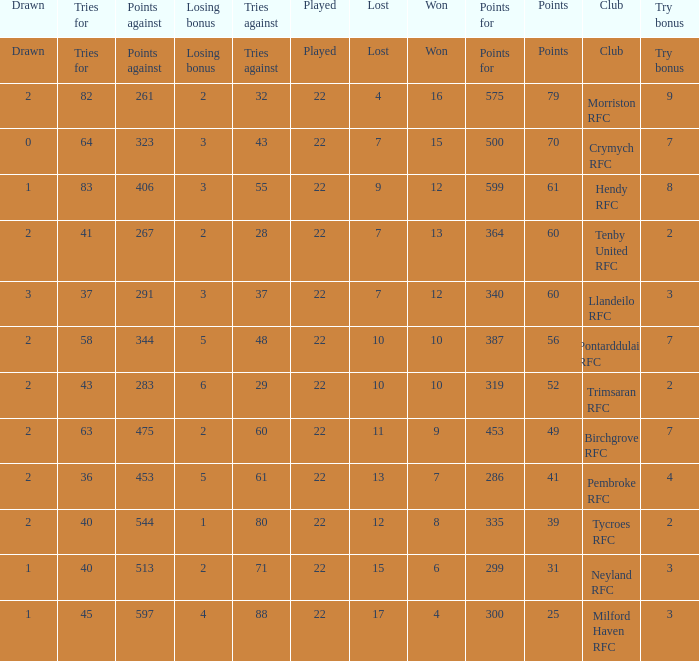 how many losing bonus with won being 10 and points against being 283 1.0. 